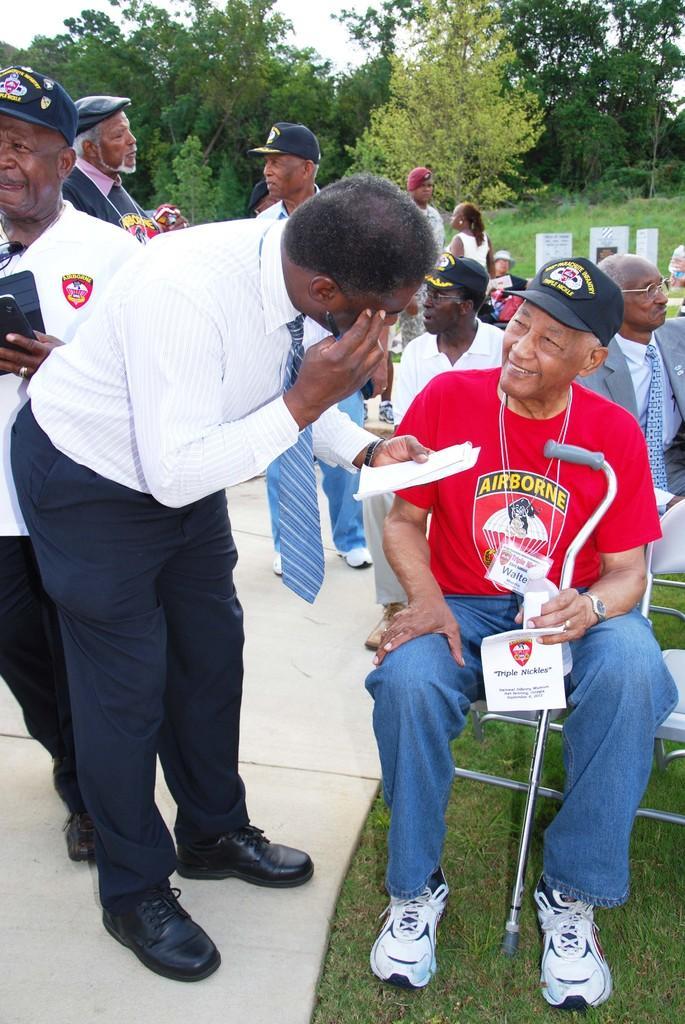Describe this image in one or two sentences. The man in front of the picture wearing a red t-shirt and blue jeans who is wearing black cap is holding paper and stick in his hand and he is smiling. Beside him, a man in white shirt and black pant is standing and talking to the man beside him. Behind them, we see people standing and we even see people sitting on chairs. There are many trees in the background. At the bottom of the picture, we see grass and this picture might be clicked in the garden. 